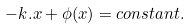Convert formula to latex. <formula><loc_0><loc_0><loc_500><loc_500>- { k } . { x } + \phi ( { x } ) = c o n s t a n t .</formula> 